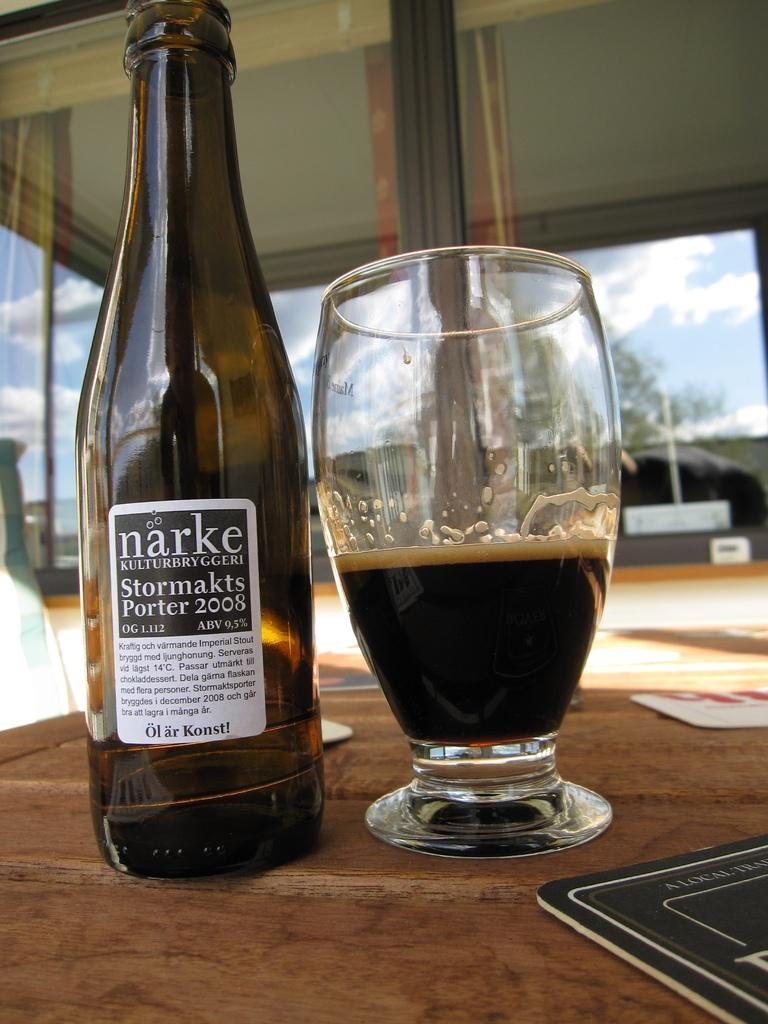<image>
Render a clear and concise summary of the photo. A bottle of narke booze next to a glass half full of booze. 